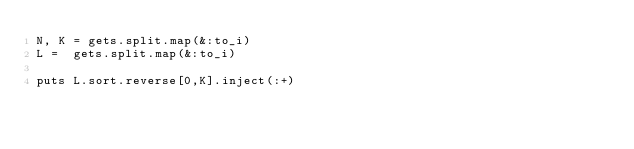Convert code to text. <code><loc_0><loc_0><loc_500><loc_500><_Ruby_>N, K = gets.split.map(&:to_i)
L =  gets.split.map(&:to_i)

puts L.sort.reverse[0,K].inject(:+)</code> 